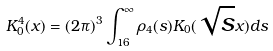<formula> <loc_0><loc_0><loc_500><loc_500>K _ { 0 } ^ { 4 } ( x ) = ( 2 \pi ) ^ { 3 } \int _ { 1 6 } ^ { \infty } \rho _ { 4 } ( s ) K _ { 0 } ( \sqrt { s } x ) d s</formula> 